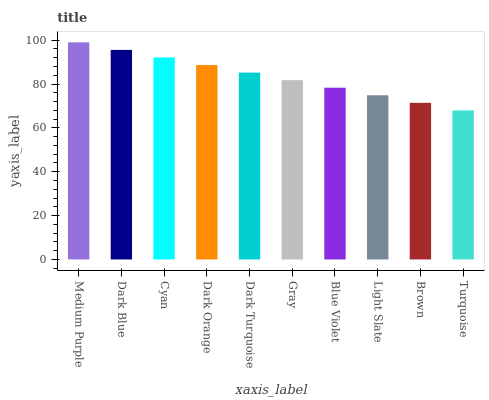Is Turquoise the minimum?
Answer yes or no. Yes. Is Medium Purple the maximum?
Answer yes or no. Yes. Is Dark Blue the minimum?
Answer yes or no. No. Is Dark Blue the maximum?
Answer yes or no. No. Is Medium Purple greater than Dark Blue?
Answer yes or no. Yes. Is Dark Blue less than Medium Purple?
Answer yes or no. Yes. Is Dark Blue greater than Medium Purple?
Answer yes or no. No. Is Medium Purple less than Dark Blue?
Answer yes or no. No. Is Dark Turquoise the high median?
Answer yes or no. Yes. Is Gray the low median?
Answer yes or no. Yes. Is Light Slate the high median?
Answer yes or no. No. Is Blue Violet the low median?
Answer yes or no. No. 